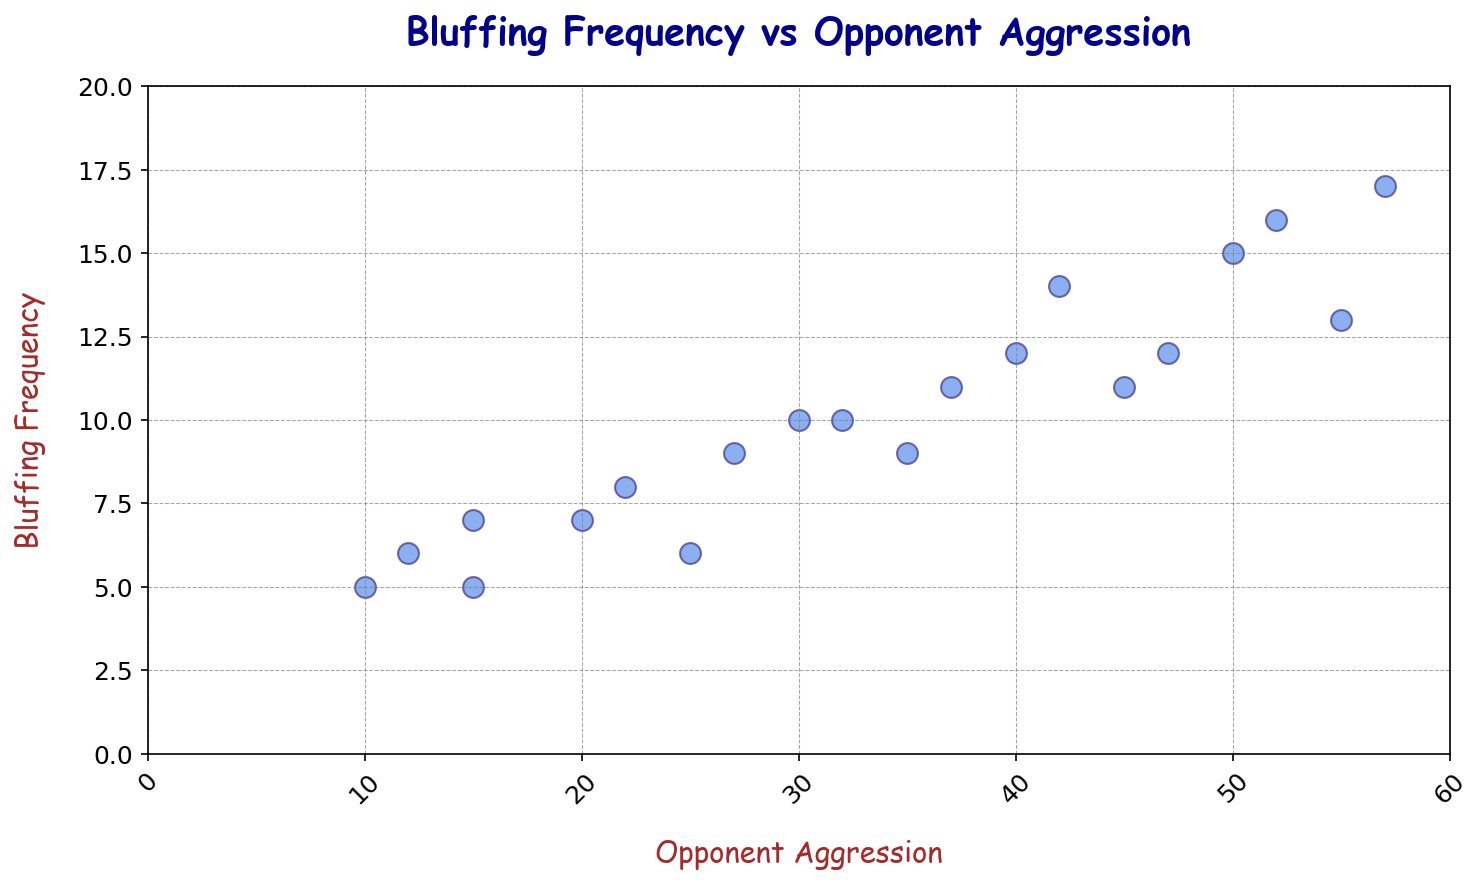What is the average bluffing frequency when opponent aggression is 20? Locate the data points where the Opponent Aggression is 20. The Bluffing Frequencies for these points are 7. Since there's only one data point, the average Bluffing Frequency is 7.
Answer: 7 When opponent aggression is 35, how much higher is the bluffing frequency compared to the opponent aggression of 15? Find the Bluffing Frequency at Opponent Aggression of 35 (9) and 15 (5, 7, 7). Calculate the difference: 9 - ((5+7+7)/3) = 9 - 6.33.
Answer: 2.67 Is there a data point where the bluffing frequency and opponent aggression levels are both even numbers? Review the data points for both values to be even. Opponent Aggression of 30 and Bluffing Frequency of 10 is a match.
Answer: Yes What is the correlation trend between bluffing frequency and opponent aggression? Observe the scatter plot and notice that as Opponent Aggression increases, Bluffing Frequency also tends to increase, indicating a positive correlation.
Answer: Positive How does the bluffing frequency of the highest opponent aggression level (57) compare with the second highest (55)? Locate the Bluffing Frequency at Opponent Aggression of 57 (17) and 55 (13). Compare 17 > 13.
Answer: Higher What is the median bluffing frequency at different opponent aggression levels: low (10 to 30), medium (31 to 45), and high (46 to 60)? Group the data points into low, medium, and high categories and find their median. Low aggression: 5, 7, 6, 10, 9, median = 7. Medium: 11, 10, 11, 12, median = 11. High: 12, 13, 16, 17, median = 14.5
Answer: 7, 11, 14.5 Is there any anomaly or outlier in the bluffing frequency data? Check if any data points deviate significantly from the trend. The data appears consistent with the positive correlation trend, no significant outliers.
Answer: No Which data point has the largest difference in opponent aggression and bluffing frequency? Calculate the difference for each data point between Opponent Aggression and Bluffing Frequency. The data point with the largest difference is (16, 52) with a difference of 36.
Answer: (16, 52) How many data points have bluffing frequencies above the average bluffing frequency across all data points? Calculate the average Bluffing Frequency: (sum of all Bluffing Frequencies / number of data points) which is (201/20) = 10.05. Count the data points above 10. There are 8 such points.
Answer: 8 